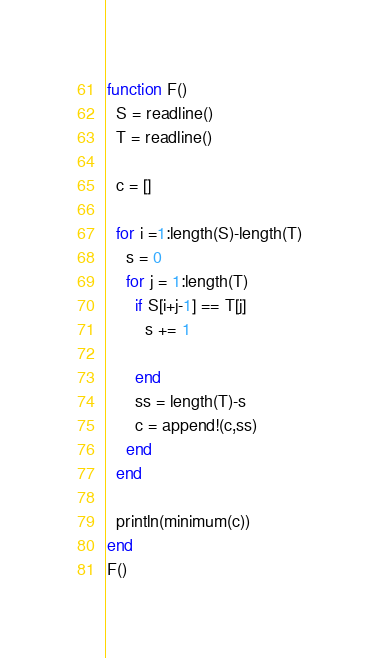<code> <loc_0><loc_0><loc_500><loc_500><_Julia_>function F()
  S = readline()
  T = readline()
 
  c = []
  
  for i =1:length(S)-length(T)
    s = 0
    for j = 1:length(T)
      if S[i+j-1] == T[j]
        s += 1
      
      end
      ss = length(T)-s
      c = append!(c,ss)
    end
  end
  
  println(minimum(c))
end
F()</code> 